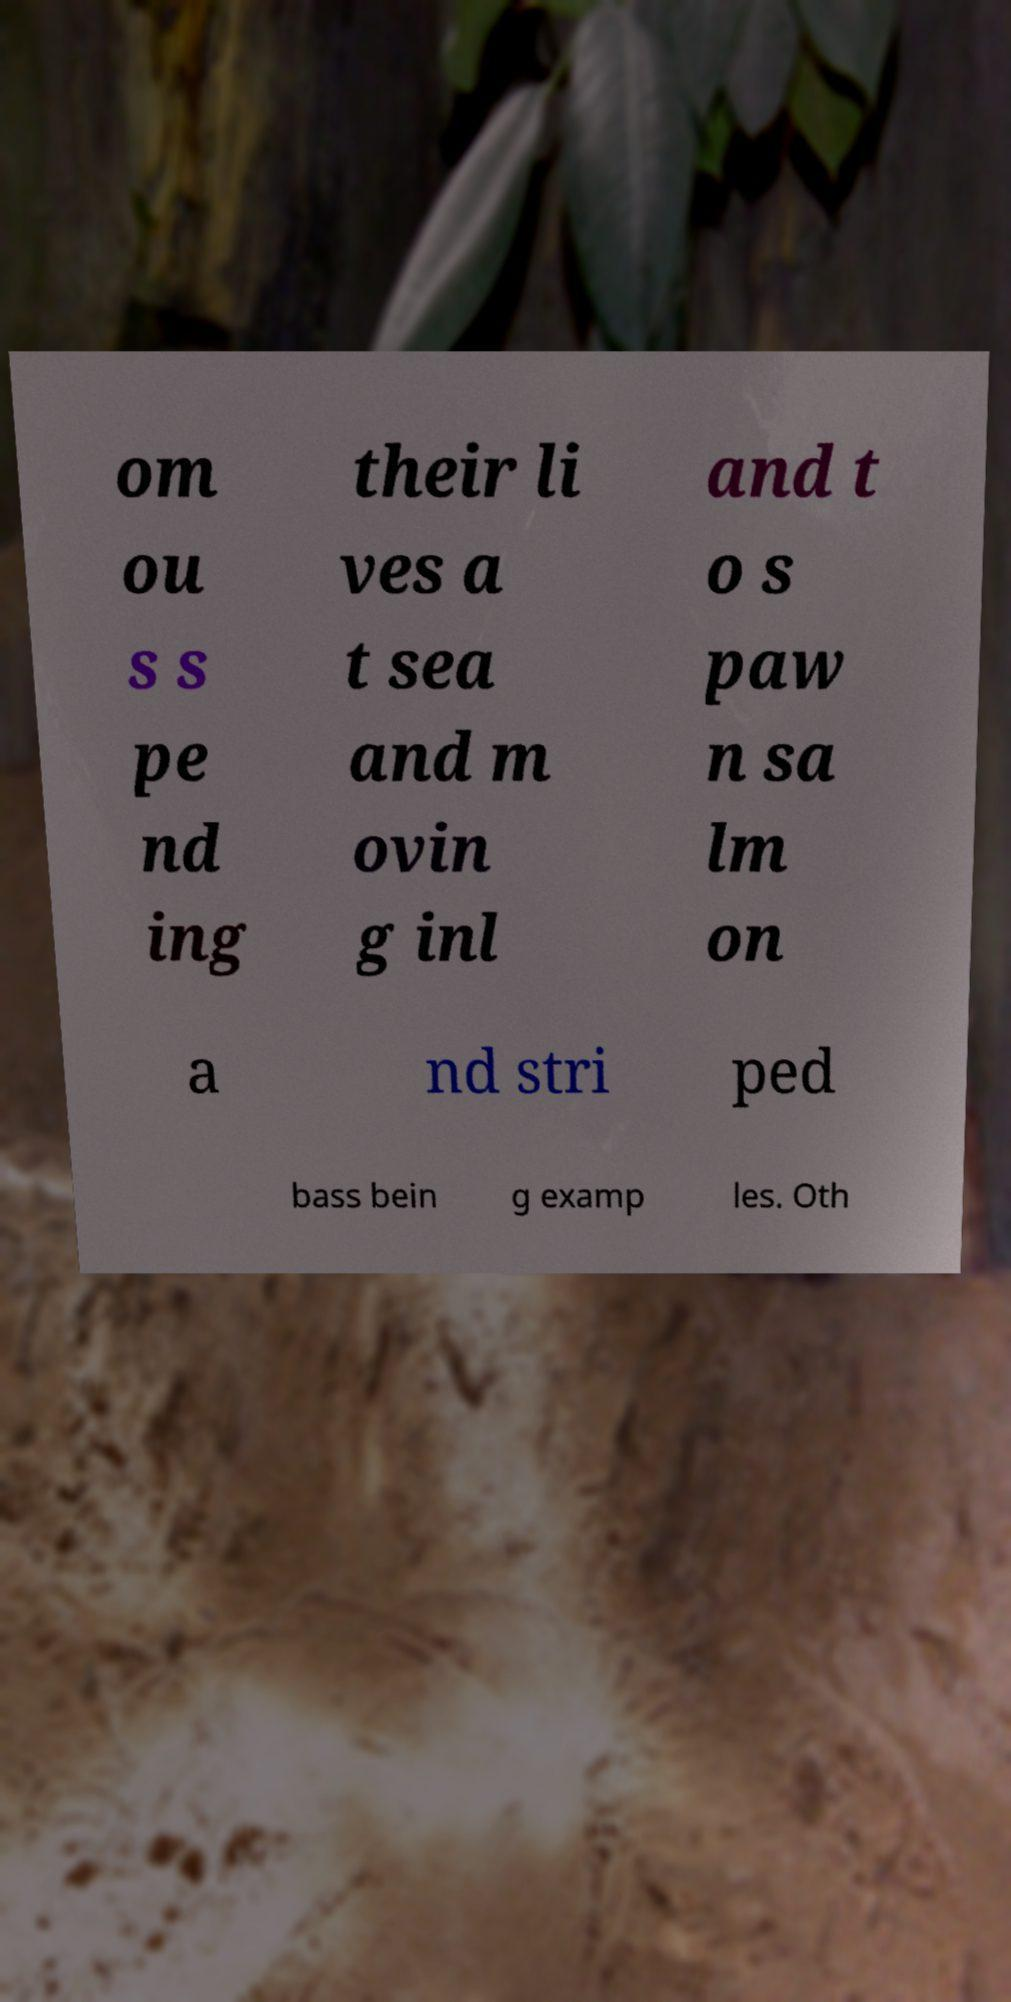I need the written content from this picture converted into text. Can you do that? om ou s s pe nd ing their li ves a t sea and m ovin g inl and t o s paw n sa lm on a nd stri ped bass bein g examp les. Oth 